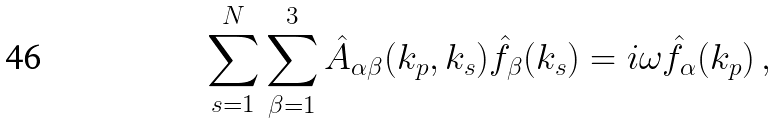<formula> <loc_0><loc_0><loc_500><loc_500>\sum _ { s = 1 } ^ { N } \sum _ { \beta = 1 } ^ { 3 } \hat { A } _ { \alpha \beta } ( k _ { p } , k _ { s } ) \hat { f } _ { \beta } ( k _ { s } ) = i \omega \hat { f } _ { \alpha } ( k _ { p } ) \, ,</formula> 